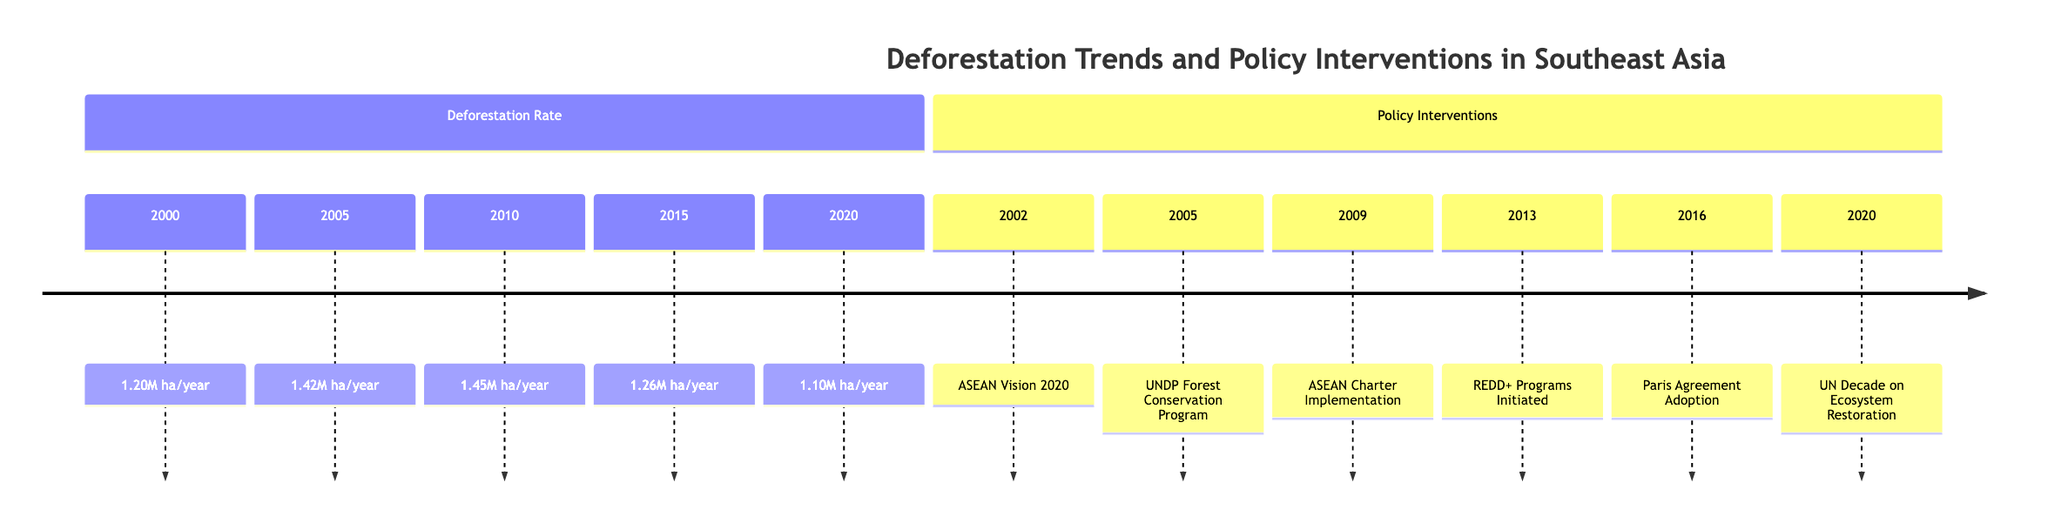What was the deforestation rate in 2005? The diagram indicates that the deforestation rate in 2005 is explicitly stated as 1.42 million hectares per year.
Answer: 1.42M ha/year Which policy intervention was implemented in 2002? From the diagram, the policy intervention listed for 2002 is the ASEAN Vision 2020, clearly noted in the section on Policy Interventions.
Answer: ASEAN Vision 2020 What is the trend of deforestation rates from 2010 to 2020? According to the timeline, the deforestation rate rises from 1.45 million hectares per year in 2010 to a decline of 1.10 million hectares per year in 2020, showing a downward trend over this period.
Answer: Decreasing How many policy interventions are listed in the diagram? By counting the instances in the Policy Interventions section of the diagram, there are a total of six interventions documented: ASEAN Vision 2020, UNDP Forest Conservation Program, ASEAN Charter Implementation, REDD+ Programs Initiated, Paris Agreement Adoption, and UN Decade on Ecosystem Restoration.
Answer: 6 What was the deforestation rate in 2015 compared to 2010? The diagram shows a deforestation rate of 1.26 million hectares per year in 2015 and 1.45 million hectares per year in 2010. The difference between these two values indicates a decrease in the deforestation rate from 2010 to 2015.
Answer: Decreased Which year saw the lowest deforestation rate in the timeline? By examining the deforestation rates provided for each year, 2020 presents the lowest figure at 1.10 million hectares per year, thus making it the year with the least deforestation rate documented.
Answer: 2020 In what year did REDD+ Programs get initiated? The timeline denotes that REDD+ Programs were initiated in 2013, providing specific information on policy interventions concerning forest conservation efforts.
Answer: 2013 What was the deforestation rate in 2010? Referring to the diagram, the deforestation rate specifically stated for the year 2010 is 1.45 million hectares per year.
Answer: 1.45M ha/year Which policy was implemented just before the Paris Agreement adoption? The timeline reveals that the policy intervention implemented immediately before the Paris Agreement in 2016 was the REDD+ Programs Initiated in 2013.
Answer: REDD+ Programs Initiated 